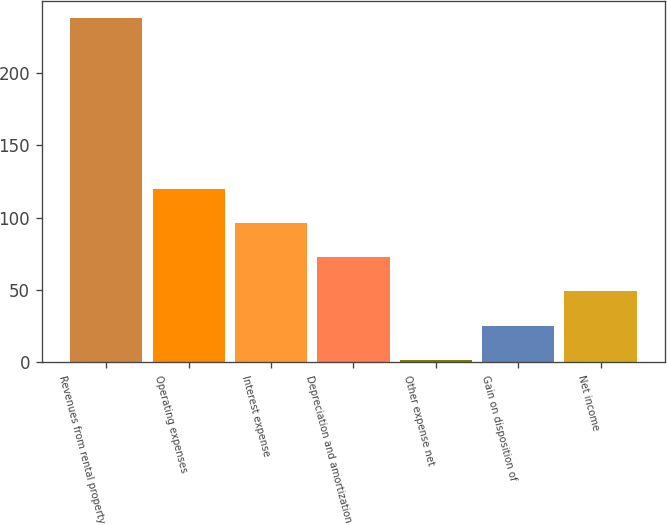Convert chart to OTSL. <chart><loc_0><loc_0><loc_500><loc_500><bar_chart><fcel>Revenues from rental property<fcel>Operating expenses<fcel>Interest expense<fcel>Depreciation and amortization<fcel>Other expense net<fcel>Gain on disposition of<fcel>Net income<nl><fcel>238<fcel>119.85<fcel>96.22<fcel>72.59<fcel>1.7<fcel>25.33<fcel>48.96<nl></chart> 